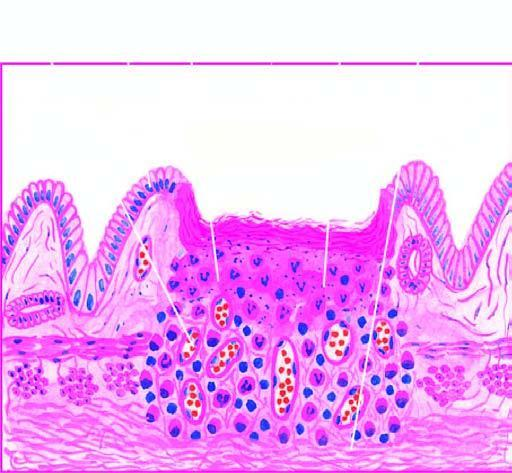what shows necrotic debris, ulceration and inflammation on the mucosal surface?
Answer the question using a single word or phrase. Yes 